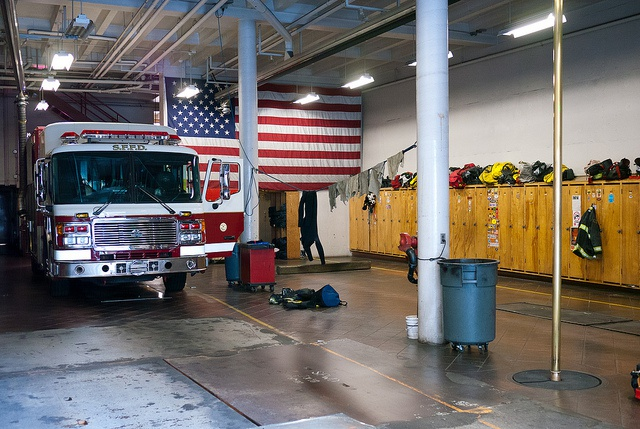Describe the objects in this image and their specific colors. I can see a truck in black, lightgray, gray, and darkgray tones in this image. 